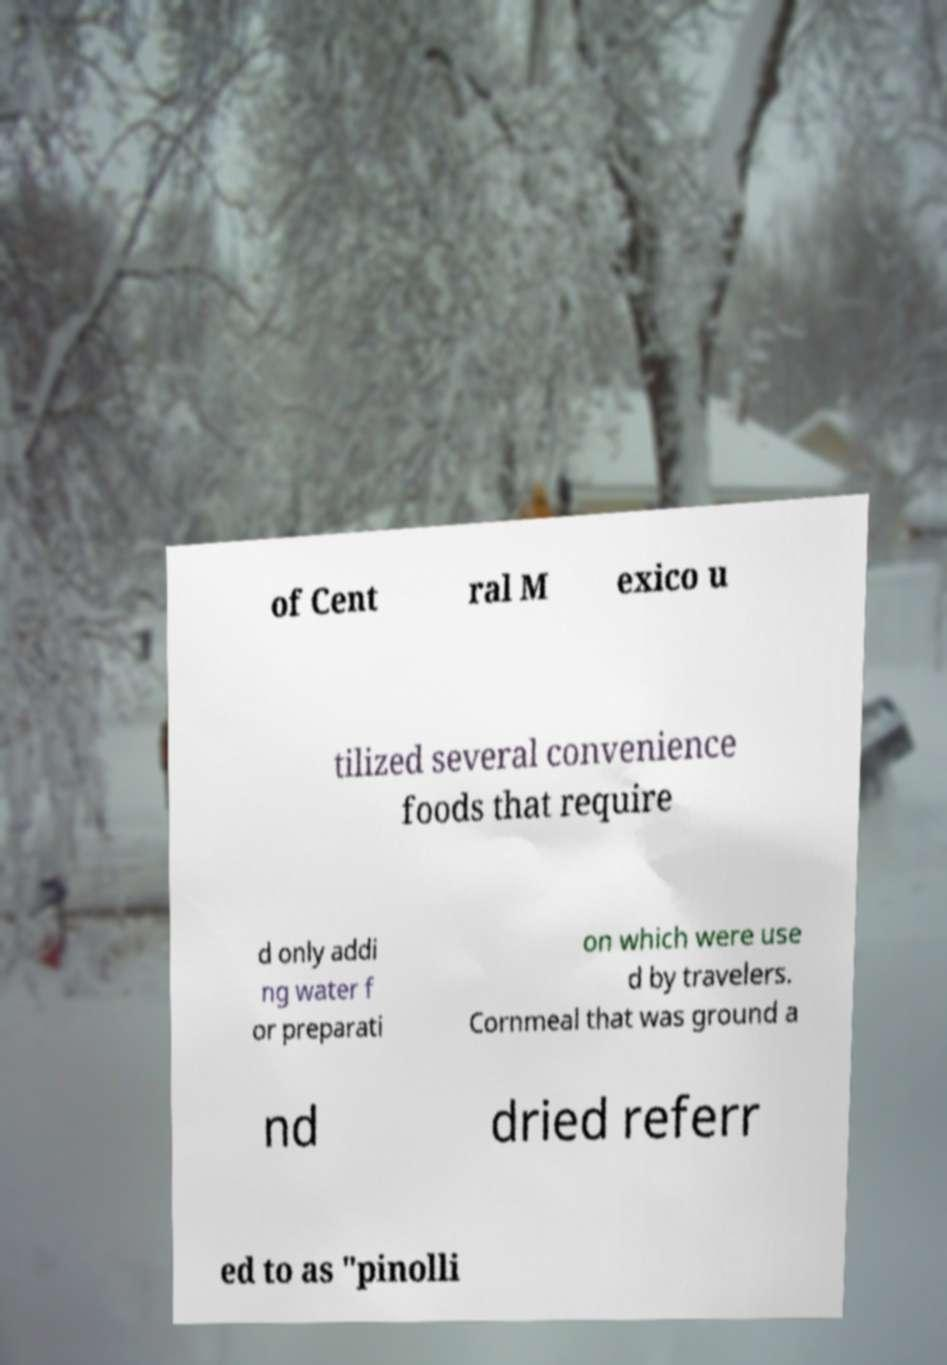There's text embedded in this image that I need extracted. Can you transcribe it verbatim? of Cent ral M exico u tilized several convenience foods that require d only addi ng water f or preparati on which were use d by travelers. Cornmeal that was ground a nd dried referr ed to as "pinolli 